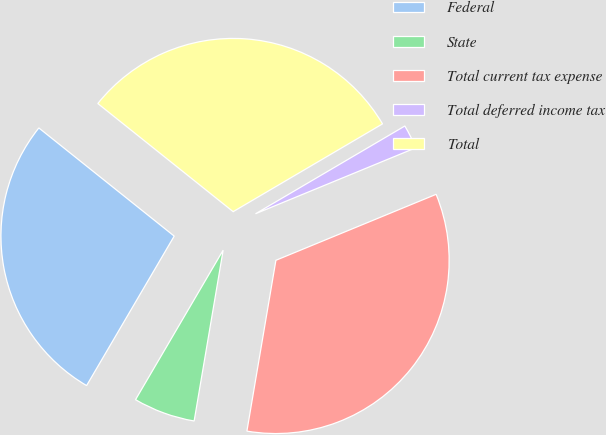Convert chart to OTSL. <chart><loc_0><loc_0><loc_500><loc_500><pie_chart><fcel>Federal<fcel>State<fcel>Total current tax expense<fcel>Total deferred income tax<fcel>Total<nl><fcel>27.29%<fcel>5.76%<fcel>33.89%<fcel>2.24%<fcel>30.81%<nl></chart> 